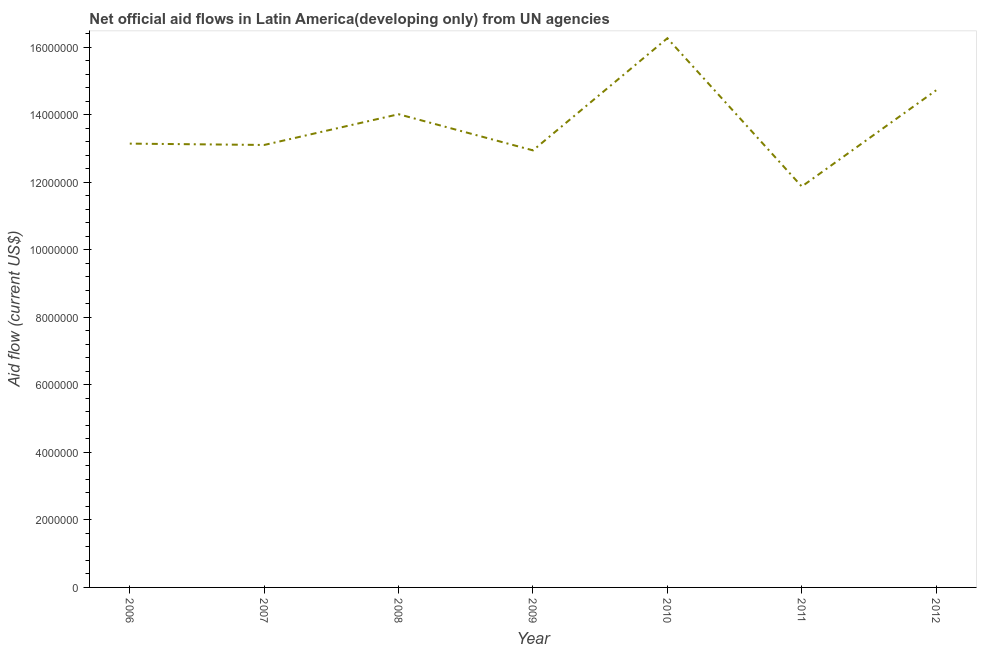What is the net official flows from un agencies in 2010?
Ensure brevity in your answer.  1.63e+07. Across all years, what is the maximum net official flows from un agencies?
Give a very brief answer. 1.63e+07. Across all years, what is the minimum net official flows from un agencies?
Keep it short and to the point. 1.19e+07. What is the sum of the net official flows from un agencies?
Your answer should be compact. 9.60e+07. What is the difference between the net official flows from un agencies in 2007 and 2010?
Ensure brevity in your answer.  -3.16e+06. What is the average net official flows from un agencies per year?
Your response must be concise. 1.37e+07. What is the median net official flows from un agencies?
Your answer should be compact. 1.31e+07. In how many years, is the net official flows from un agencies greater than 1200000 US$?
Ensure brevity in your answer.  7. Do a majority of the years between 2010 and 2007 (inclusive) have net official flows from un agencies greater than 2400000 US$?
Make the answer very short. Yes. What is the ratio of the net official flows from un agencies in 2009 to that in 2010?
Give a very brief answer. 0.8. What is the difference between the highest and the second highest net official flows from un agencies?
Your response must be concise. 1.54e+06. Is the sum of the net official flows from un agencies in 2008 and 2012 greater than the maximum net official flows from un agencies across all years?
Offer a terse response. Yes. What is the difference between the highest and the lowest net official flows from un agencies?
Your response must be concise. 4.39e+06. Does the net official flows from un agencies monotonically increase over the years?
Ensure brevity in your answer.  No. How many lines are there?
Offer a terse response. 1. How many years are there in the graph?
Keep it short and to the point. 7. Does the graph contain any zero values?
Offer a terse response. No. What is the title of the graph?
Keep it short and to the point. Net official aid flows in Latin America(developing only) from UN agencies. What is the label or title of the X-axis?
Your response must be concise. Year. What is the label or title of the Y-axis?
Provide a succinct answer. Aid flow (current US$). What is the Aid flow (current US$) of 2006?
Give a very brief answer. 1.31e+07. What is the Aid flow (current US$) in 2007?
Provide a short and direct response. 1.31e+07. What is the Aid flow (current US$) of 2008?
Make the answer very short. 1.40e+07. What is the Aid flow (current US$) of 2009?
Offer a very short reply. 1.29e+07. What is the Aid flow (current US$) in 2010?
Provide a short and direct response. 1.63e+07. What is the Aid flow (current US$) of 2011?
Ensure brevity in your answer.  1.19e+07. What is the Aid flow (current US$) in 2012?
Offer a very short reply. 1.47e+07. What is the difference between the Aid flow (current US$) in 2006 and 2008?
Your response must be concise. -8.70e+05. What is the difference between the Aid flow (current US$) in 2006 and 2010?
Provide a short and direct response. -3.12e+06. What is the difference between the Aid flow (current US$) in 2006 and 2011?
Your answer should be compact. 1.27e+06. What is the difference between the Aid flow (current US$) in 2006 and 2012?
Give a very brief answer. -1.58e+06. What is the difference between the Aid flow (current US$) in 2007 and 2008?
Ensure brevity in your answer.  -9.10e+05. What is the difference between the Aid flow (current US$) in 2007 and 2010?
Provide a short and direct response. -3.16e+06. What is the difference between the Aid flow (current US$) in 2007 and 2011?
Give a very brief answer. 1.23e+06. What is the difference between the Aid flow (current US$) in 2007 and 2012?
Ensure brevity in your answer.  -1.62e+06. What is the difference between the Aid flow (current US$) in 2008 and 2009?
Your answer should be compact. 1.07e+06. What is the difference between the Aid flow (current US$) in 2008 and 2010?
Offer a terse response. -2.25e+06. What is the difference between the Aid flow (current US$) in 2008 and 2011?
Provide a succinct answer. 2.14e+06. What is the difference between the Aid flow (current US$) in 2008 and 2012?
Provide a short and direct response. -7.10e+05. What is the difference between the Aid flow (current US$) in 2009 and 2010?
Keep it short and to the point. -3.32e+06. What is the difference between the Aid flow (current US$) in 2009 and 2011?
Offer a terse response. 1.07e+06. What is the difference between the Aid flow (current US$) in 2009 and 2012?
Your response must be concise. -1.78e+06. What is the difference between the Aid flow (current US$) in 2010 and 2011?
Provide a succinct answer. 4.39e+06. What is the difference between the Aid flow (current US$) in 2010 and 2012?
Offer a terse response. 1.54e+06. What is the difference between the Aid flow (current US$) in 2011 and 2012?
Offer a very short reply. -2.85e+06. What is the ratio of the Aid flow (current US$) in 2006 to that in 2007?
Provide a short and direct response. 1. What is the ratio of the Aid flow (current US$) in 2006 to that in 2008?
Keep it short and to the point. 0.94. What is the ratio of the Aid flow (current US$) in 2006 to that in 2010?
Your answer should be very brief. 0.81. What is the ratio of the Aid flow (current US$) in 2006 to that in 2011?
Offer a terse response. 1.11. What is the ratio of the Aid flow (current US$) in 2006 to that in 2012?
Ensure brevity in your answer.  0.89. What is the ratio of the Aid flow (current US$) in 2007 to that in 2008?
Keep it short and to the point. 0.94. What is the ratio of the Aid flow (current US$) in 2007 to that in 2010?
Your answer should be very brief. 0.81. What is the ratio of the Aid flow (current US$) in 2007 to that in 2011?
Provide a succinct answer. 1.1. What is the ratio of the Aid flow (current US$) in 2007 to that in 2012?
Your response must be concise. 0.89. What is the ratio of the Aid flow (current US$) in 2008 to that in 2009?
Provide a short and direct response. 1.08. What is the ratio of the Aid flow (current US$) in 2008 to that in 2010?
Offer a terse response. 0.86. What is the ratio of the Aid flow (current US$) in 2008 to that in 2011?
Your response must be concise. 1.18. What is the ratio of the Aid flow (current US$) in 2008 to that in 2012?
Your answer should be very brief. 0.95. What is the ratio of the Aid flow (current US$) in 2009 to that in 2010?
Your answer should be compact. 0.8. What is the ratio of the Aid flow (current US$) in 2009 to that in 2011?
Give a very brief answer. 1.09. What is the ratio of the Aid flow (current US$) in 2009 to that in 2012?
Keep it short and to the point. 0.88. What is the ratio of the Aid flow (current US$) in 2010 to that in 2011?
Provide a short and direct response. 1.37. What is the ratio of the Aid flow (current US$) in 2010 to that in 2012?
Keep it short and to the point. 1.1. What is the ratio of the Aid flow (current US$) in 2011 to that in 2012?
Your response must be concise. 0.81. 